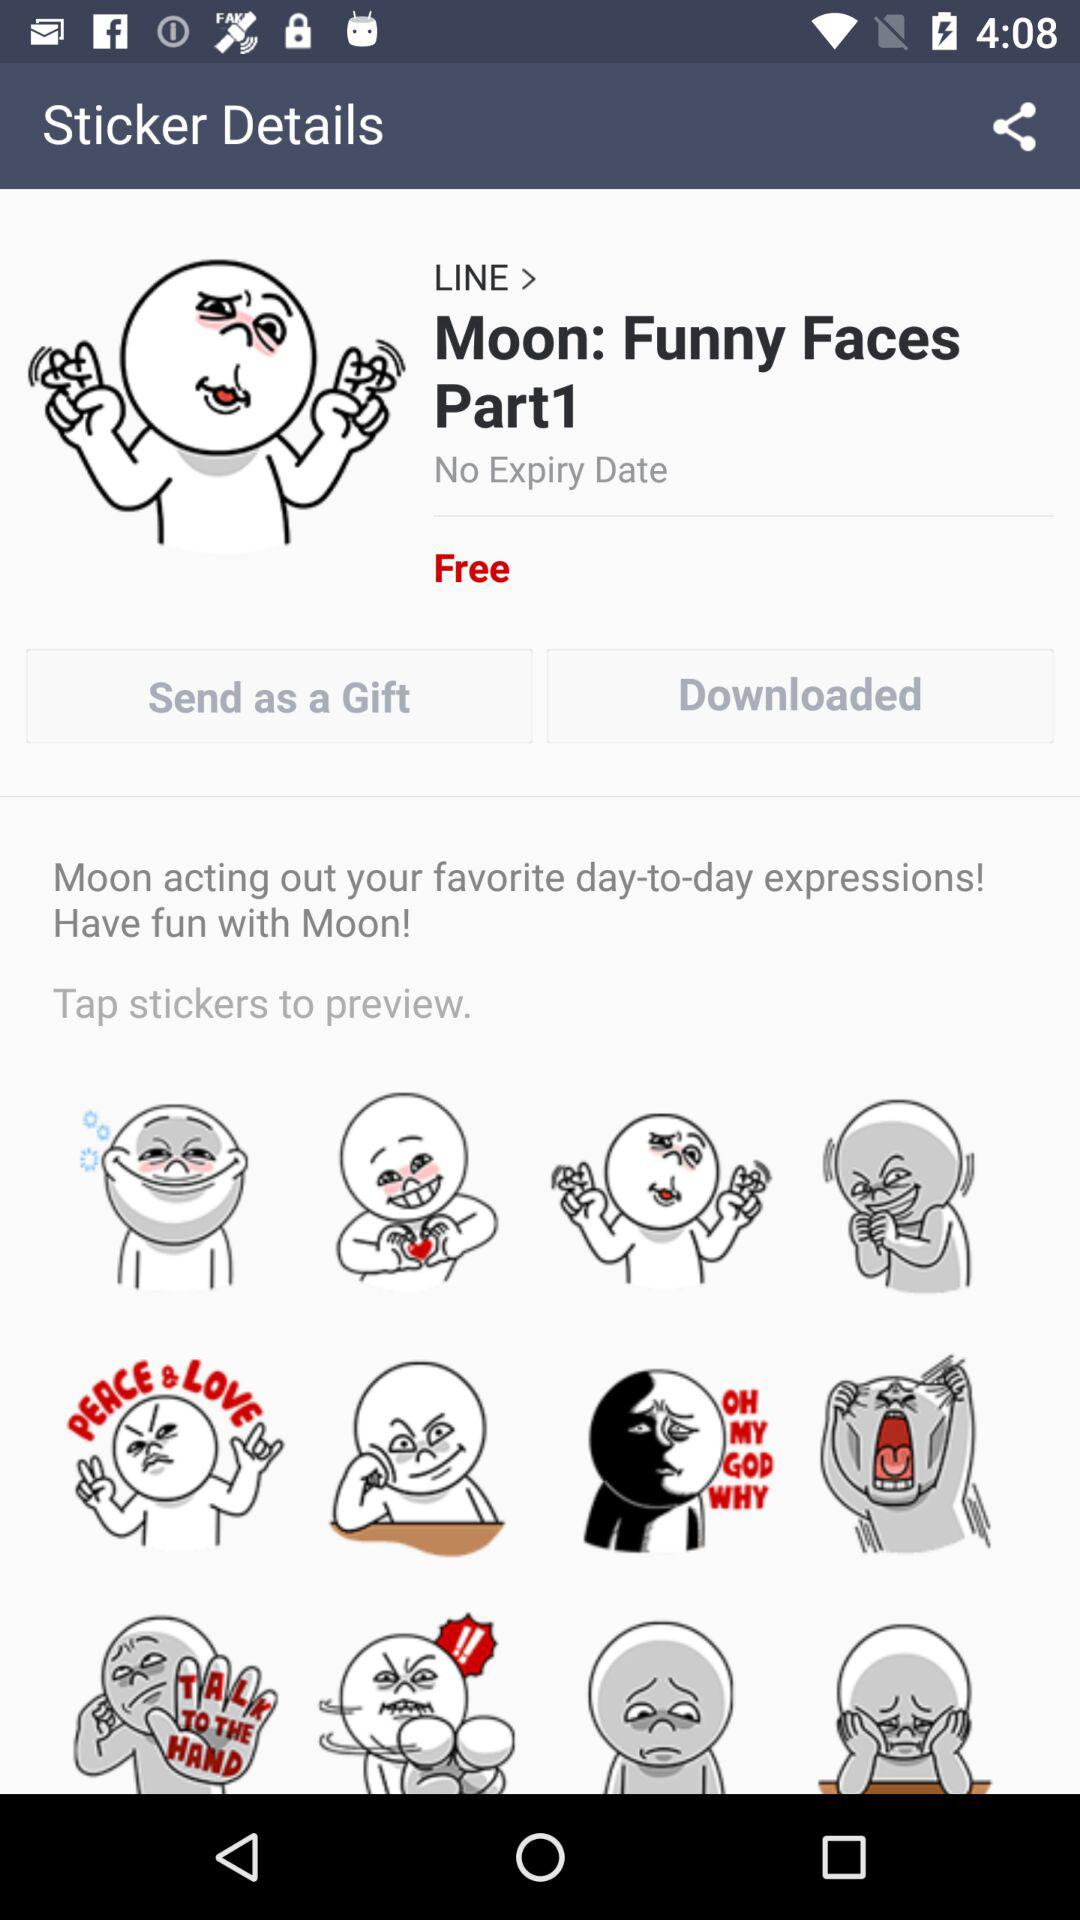What is the expiry date of the sticker? There is no expiry date. 